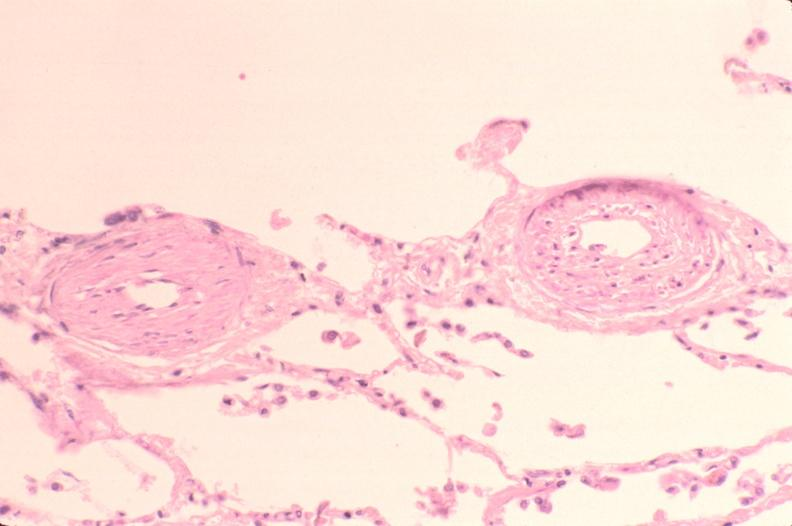where is this?
Answer the question using a single word or phrase. Lung 